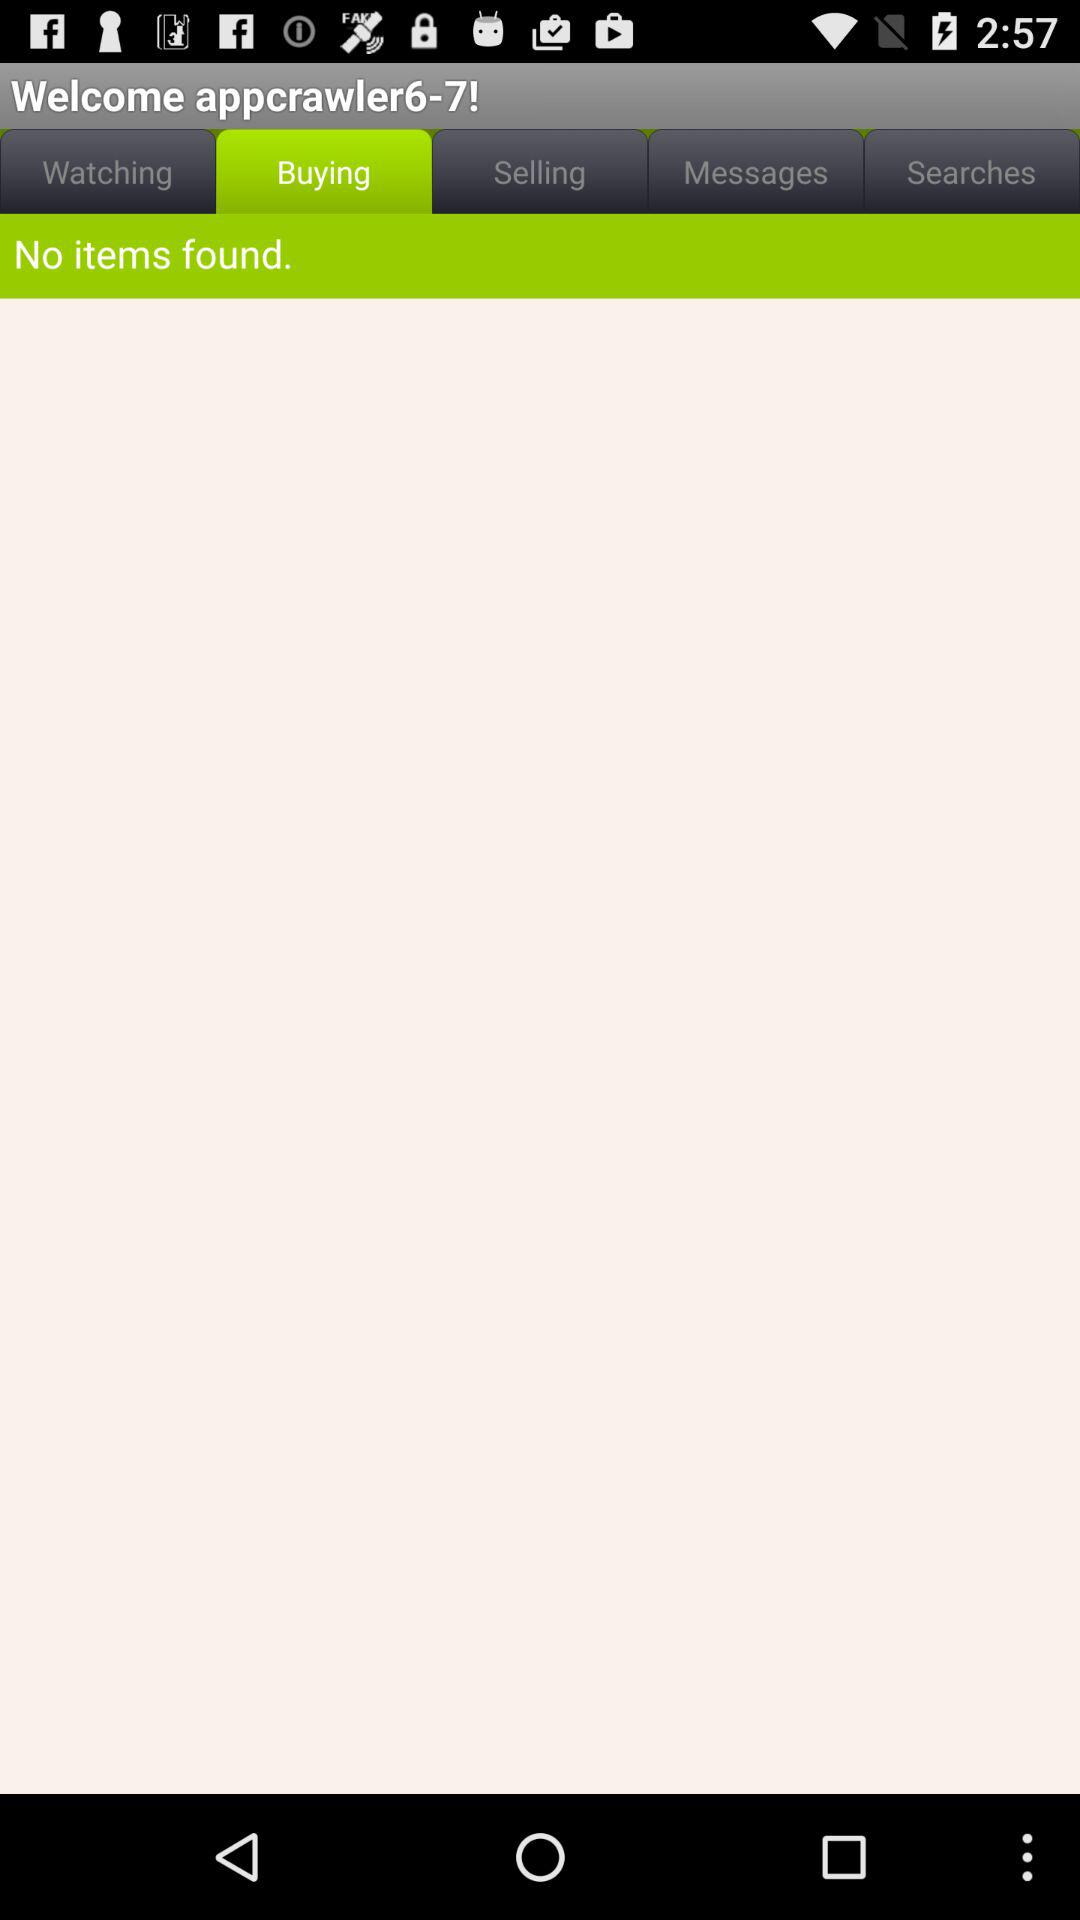Which tab is selected? The selected tab is "Buying". 